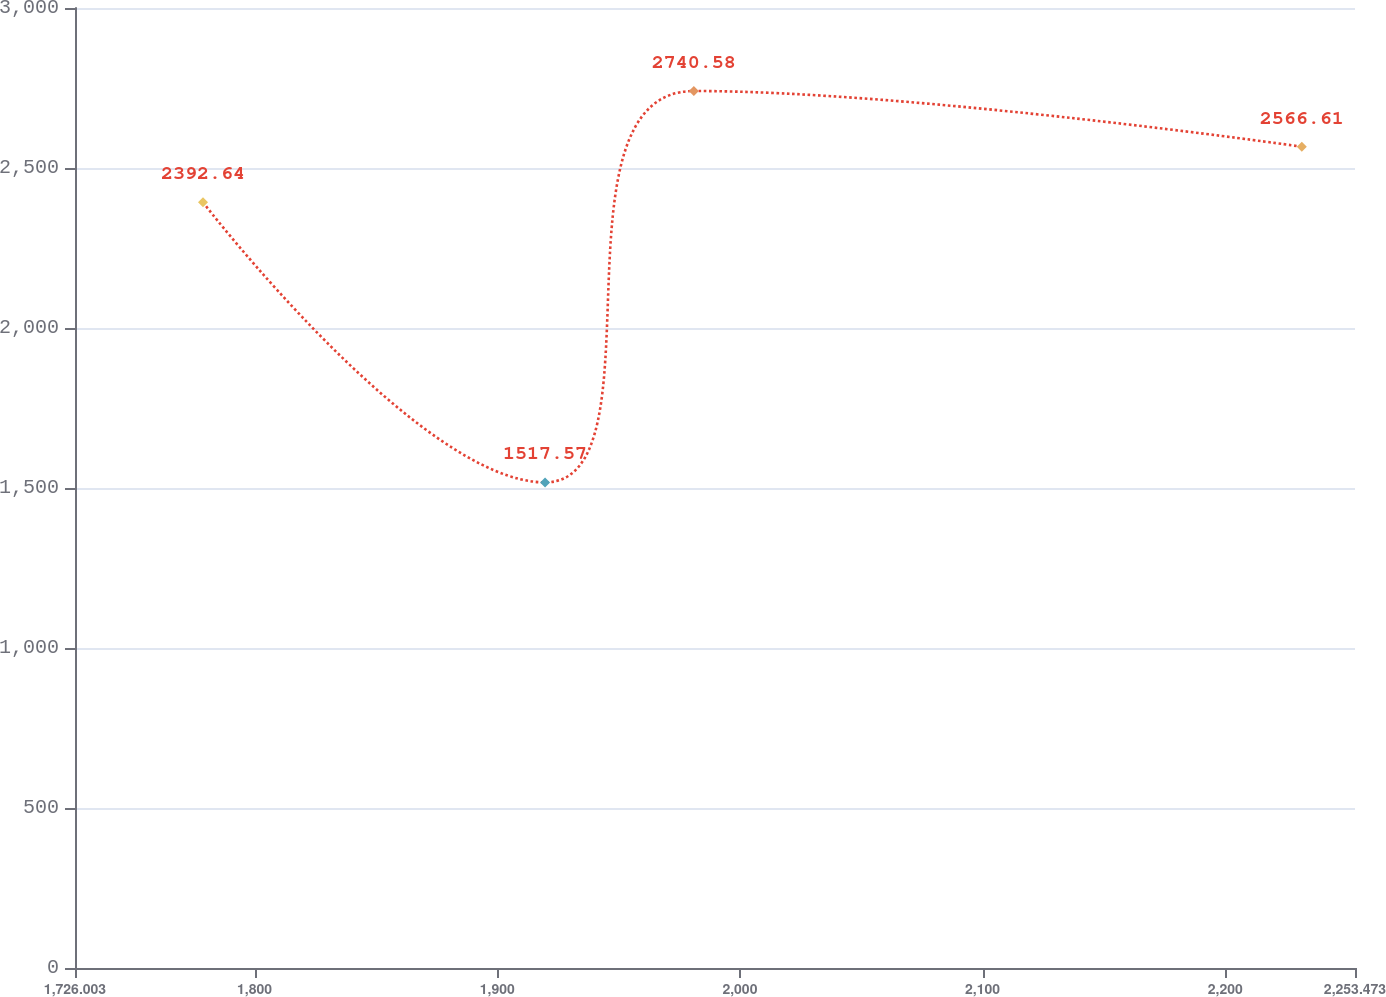Convert chart to OTSL. <chart><loc_0><loc_0><loc_500><loc_500><line_chart><ecel><fcel>Total<nl><fcel>1778.75<fcel>2392.64<nl><fcel>1919.72<fcel>1517.57<nl><fcel>1981.02<fcel>2740.58<nl><fcel>2231.56<fcel>2566.61<nl><fcel>2306.22<fcel>3257.28<nl></chart> 